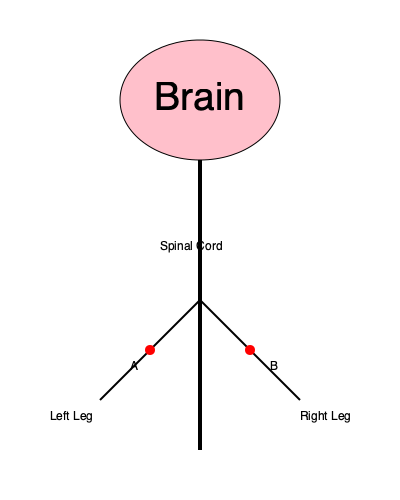In the diagram of the human nervous system, red spots A and B indicate areas affected by a rare neurological disorder. Which of the following symptoms would most likely be associated with this condition? To answer this question, let's analyze the diagram and consider the implications of the affected areas:

1. The red spots A and B are located on the spinal cord, specifically in the lower region.

2. This lower region of the spinal cord is responsible for innervating the lower limbs (legs).

3. The affected areas are symmetrical, meaning both sides of the spinal cord are involved.

4. When the spinal cord is affected in this manner, it typically results in bilateral symptoms (affecting both sides of the body).

5. Given the location of the affected areas, the symptoms would most likely involve the lower extremities.

6. Neurological disorders affecting the spinal cord often lead to sensory and motor disturbances.

7. Considering the rarity of the condition and the bilateral involvement of the lower spinal cord, the most likely symptoms would be:
   - Weakness or paralysis in both legs
   - Sensory disturbances (numbness, tingling) in both legs
   - Possible loss of bladder and bowel control

8. Among these symptoms, the most distinctive and severe would be bilateral leg weakness or paralysis.

Therefore, the symptom most likely associated with this rare neurological disorder, based on the affected areas shown in the diagram, would be bilateral leg weakness or paralysis.
Answer: Bilateral leg weakness or paralysis 